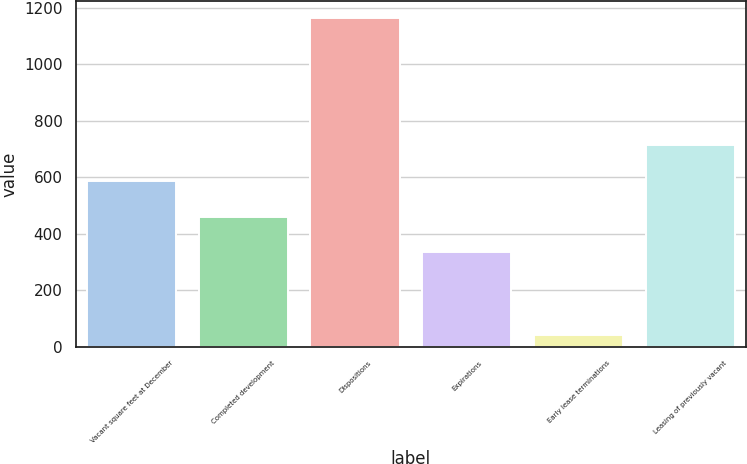Convert chart. <chart><loc_0><loc_0><loc_500><loc_500><bar_chart><fcel>Vacant square feet at December<fcel>Completed development<fcel>Dispositions<fcel>Expirations<fcel>Early lease terminations<fcel>Leasing of previously vacant<nl><fcel>587.6<fcel>460.8<fcel>1165<fcel>334<fcel>42<fcel>714.4<nl></chart> 